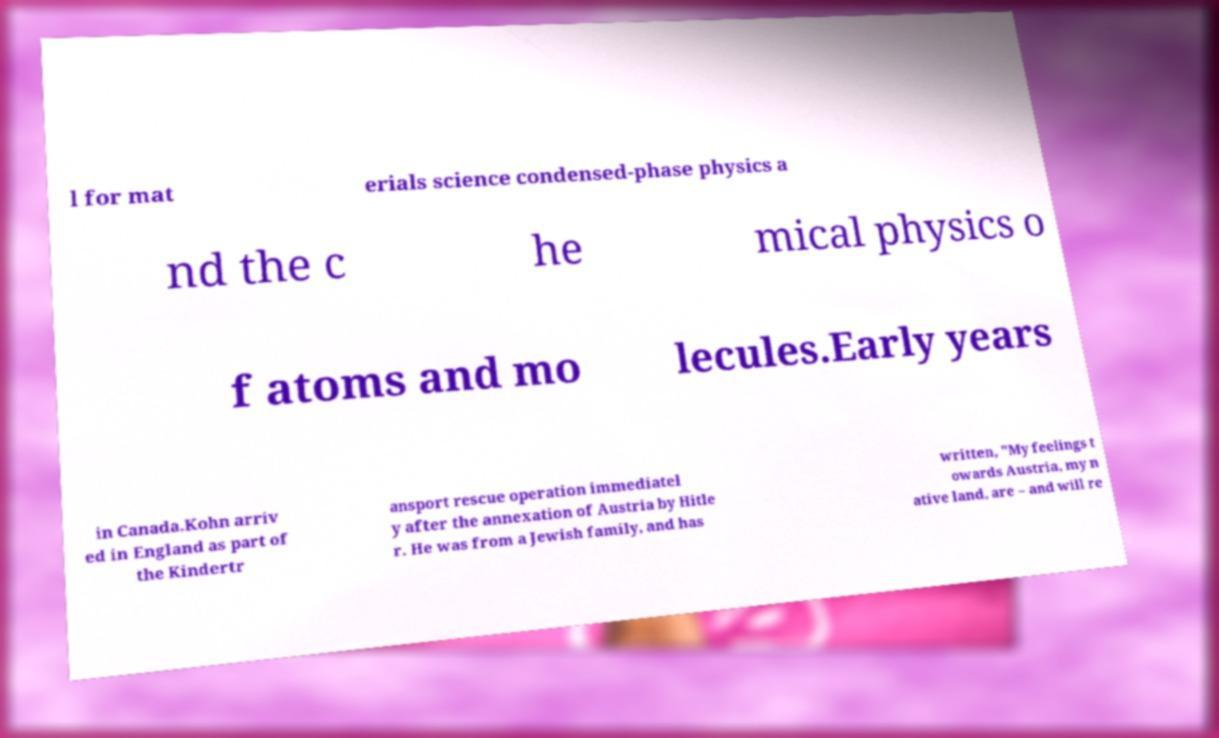For documentation purposes, I need the text within this image transcribed. Could you provide that? l for mat erials science condensed-phase physics a nd the c he mical physics o f atoms and mo lecules.Early years in Canada.Kohn arriv ed in England as part of the Kindertr ansport rescue operation immediatel y after the annexation of Austria by Hitle r. He was from a Jewish family, and has written, "My feelings t owards Austria, my n ative land, are – and will re 